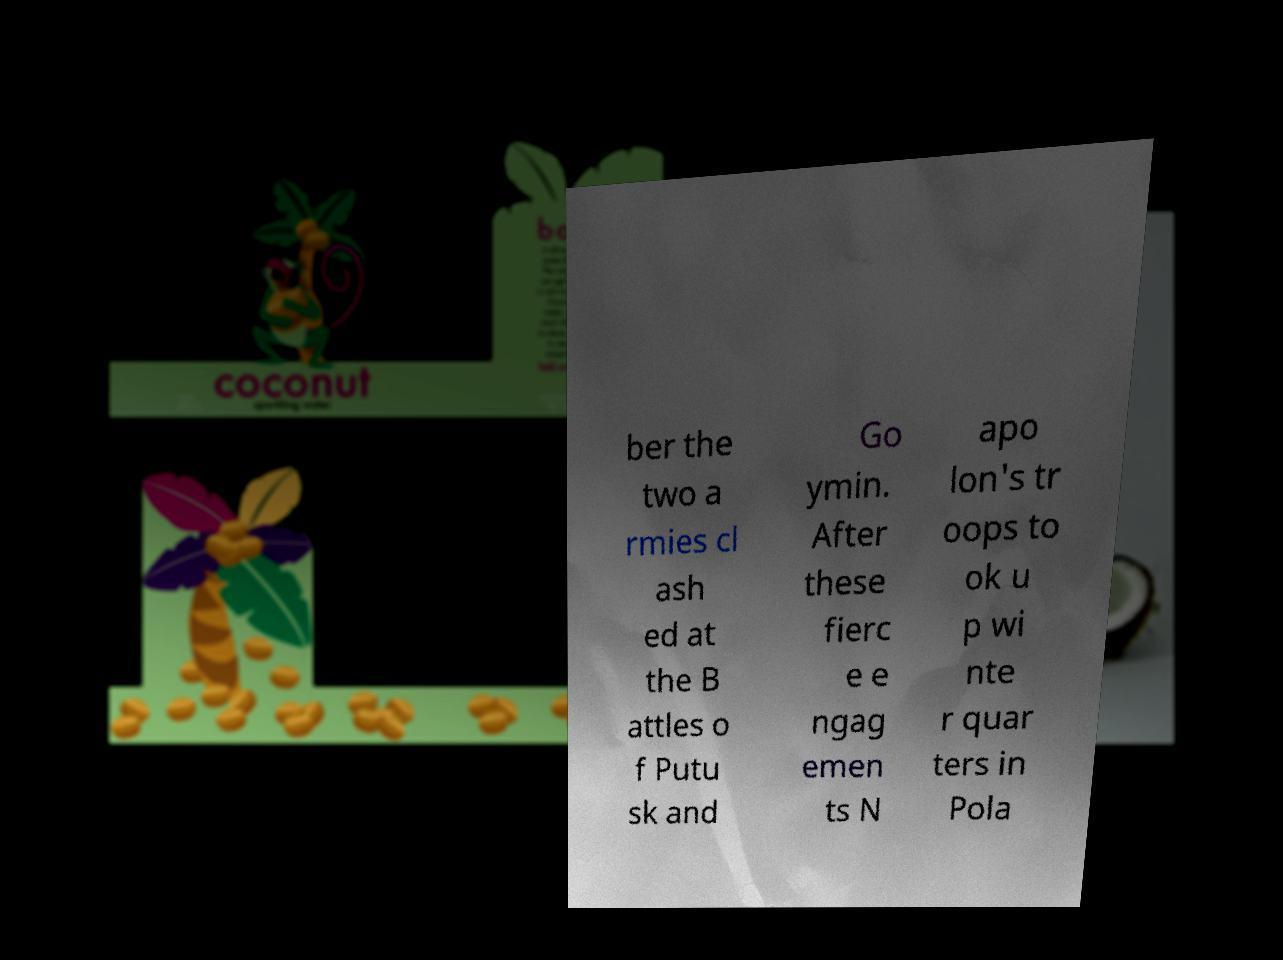For documentation purposes, I need the text within this image transcribed. Could you provide that? ber the two a rmies cl ash ed at the B attles o f Putu sk and Go ymin. After these fierc e e ngag emen ts N apo lon's tr oops to ok u p wi nte r quar ters in Pola 